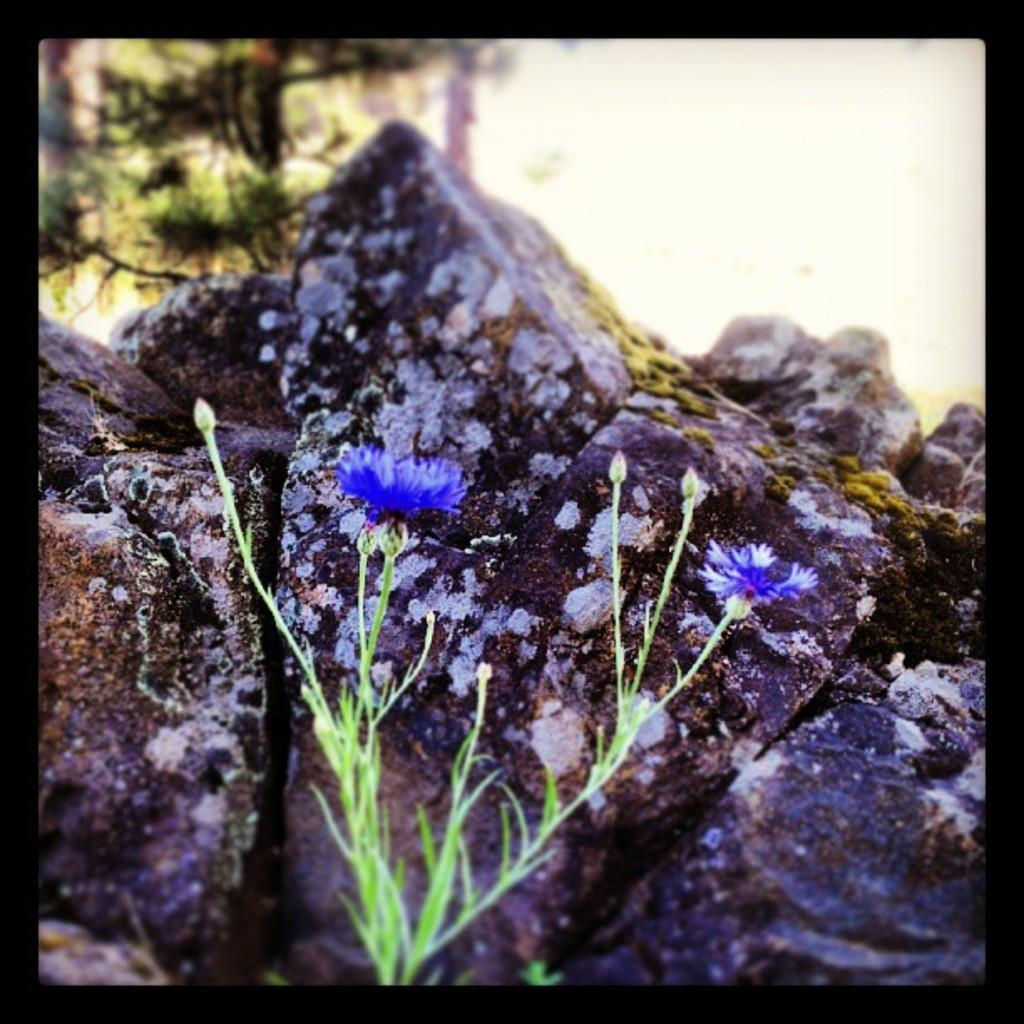What type of plant is in the image? There is a plant with flowers in the image. Where is the plant located in the image? The plant is in the center of the image. What can be seen behind the plant? There are rocks behind the plant. How would you describe the background of the image? The background of the image is blurred. What type of goldfish can be seen swimming in the image? There are no goldfish present in the image; it features a plant with flowers and rocks in the background. What is the zinc content of the plant in the image? The zinc content of the plant cannot be determined from the image alone, as it requires a chemical analysis. 